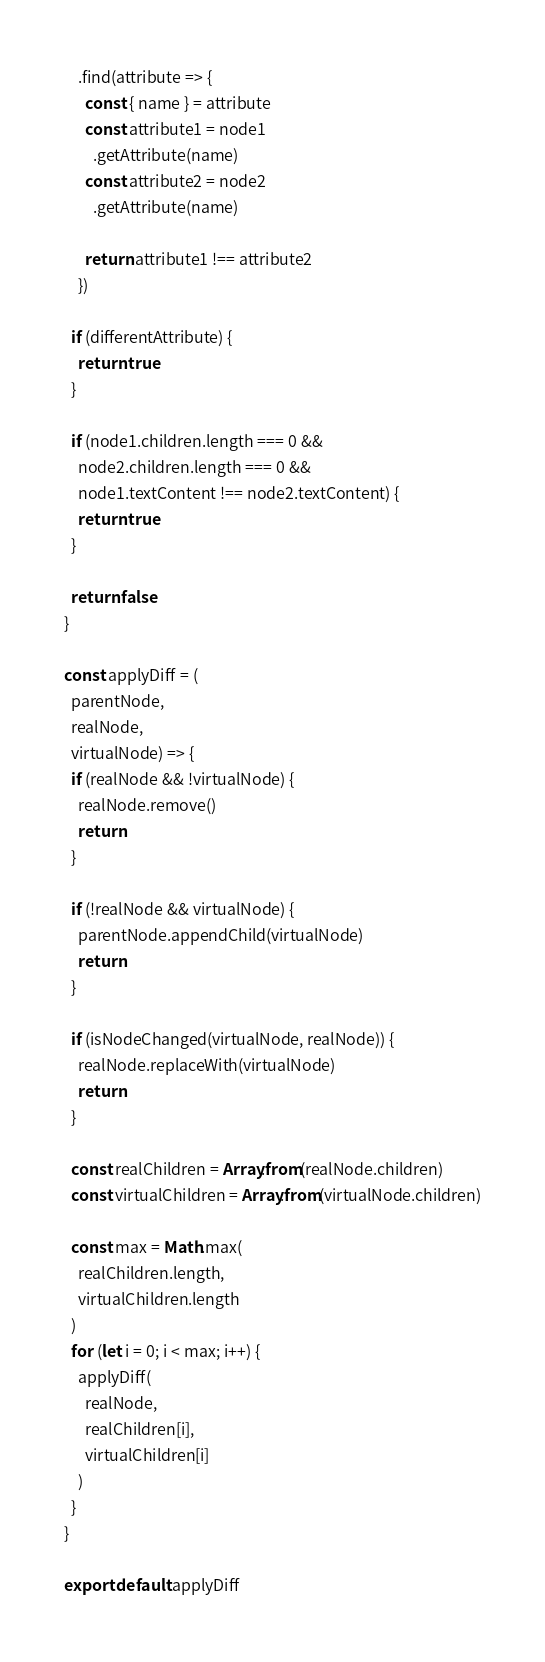Convert code to text. <code><loc_0><loc_0><loc_500><loc_500><_JavaScript_>    .find(attribute => {
      const { name } = attribute
      const attribute1 = node1
        .getAttribute(name)
      const attribute2 = node2
        .getAttribute(name)

      return attribute1 !== attribute2
    })

  if (differentAttribute) {
    return true
  }

  if (node1.children.length === 0 &&
    node2.children.length === 0 &&
    node1.textContent !== node2.textContent) {
    return true
  }

  return false
}

const applyDiff = (
  parentNode,
  realNode,
  virtualNode) => {
  if (realNode && !virtualNode) {
    realNode.remove()
    return
  }

  if (!realNode && virtualNode) {
    parentNode.appendChild(virtualNode)
    return
  }

  if (isNodeChanged(virtualNode, realNode)) {
    realNode.replaceWith(virtualNode)
    return
  }

  const realChildren = Array.from(realNode.children)
  const virtualChildren = Array.from(virtualNode.children)

  const max = Math.max(
    realChildren.length,
    virtualChildren.length
  )
  for (let i = 0; i < max; i++) {
    applyDiff(
      realNode,
      realChildren[i],
      virtualChildren[i]
    )
  }
}

export default applyDiff
</code> 